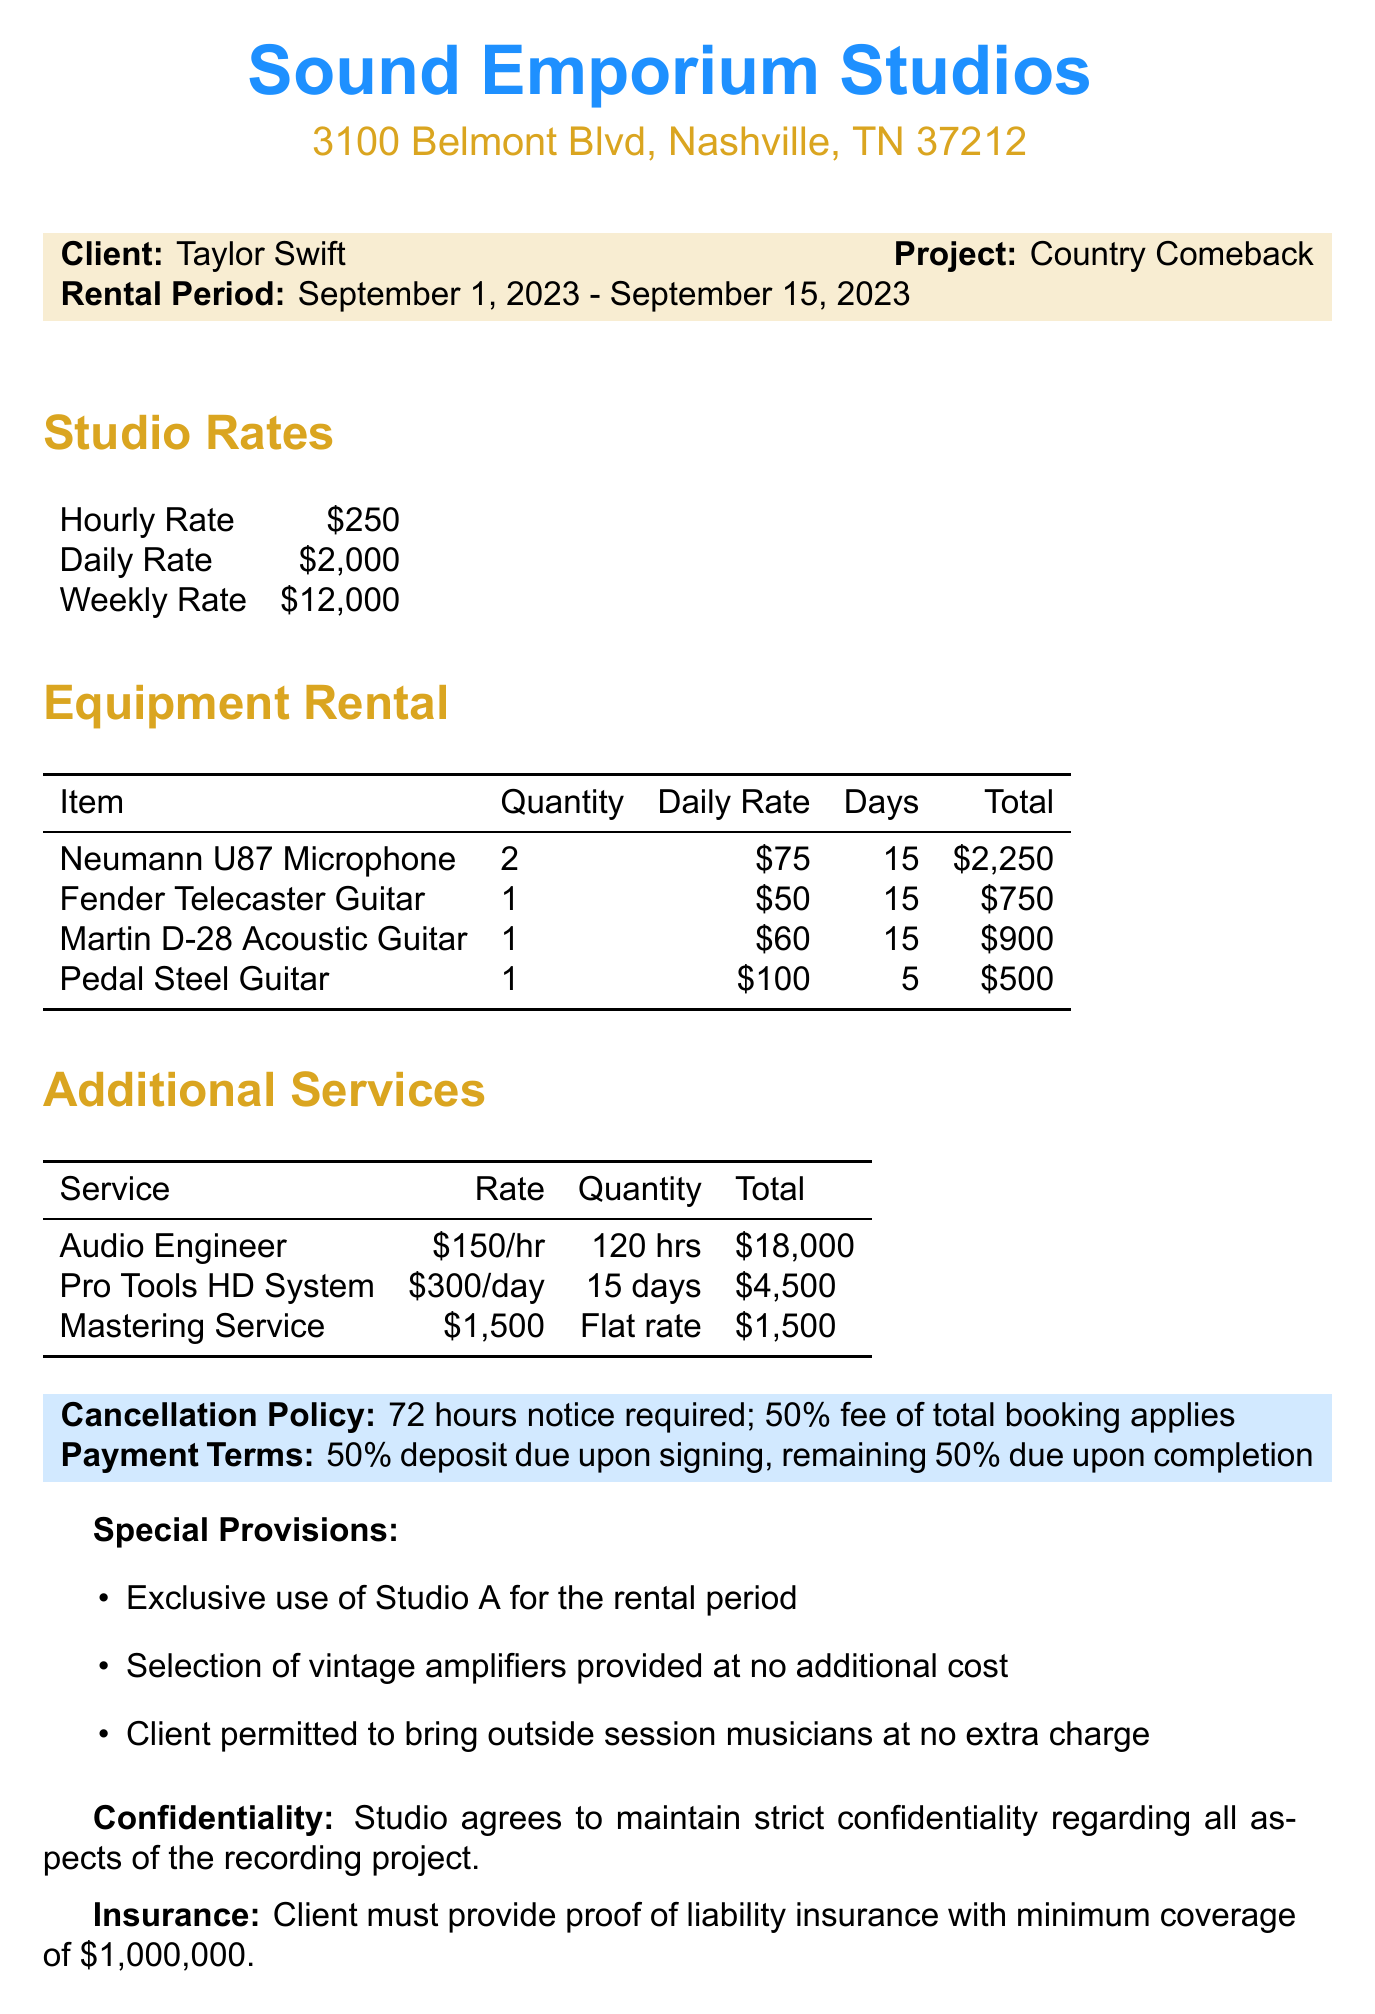what is the name of the studio? The studio name is specifically stated in the document.
Answer: Sound Emporium Studios who is the client? The client's name is clearly mentioned in the contract.
Answer: Taylor Swift what is the total daily rate for the studio? The document lists the different rates for renting the studio, including the daily rate.
Answer: $2000 what is the total number of days for equipment rental? The equipment rental section indicates a 15-day rental duration.
Answer: 15 how much is the flat rate for Mastering Service? The document specifies the flat fee for the mastering service.
Answer: $1500 what is included in the special provisions? The special provisions detail unique terms applicable during the rental period.
Answer: Exclusive use of Studio A what is the penalty for late cancellation? The document outlines the consequences for not cancelling on time.
Answer: 50% of total booking how many Neumann U87 Microphones are rented? The equipment rental section specifies the quantity of this particular item rented.
Answer: 2 what is the insurance requirement? The document states what proof the client needs to provide in terms of insurance.
Answer: $1,000,000 